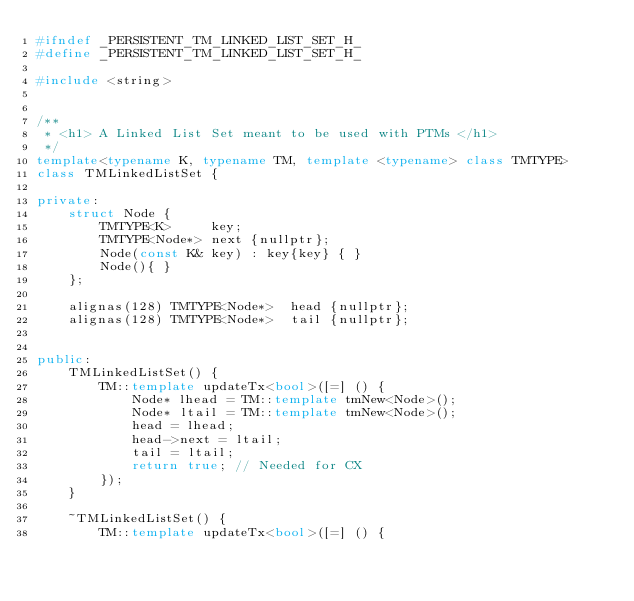<code> <loc_0><loc_0><loc_500><loc_500><_C++_>#ifndef _PERSISTENT_TM_LINKED_LIST_SET_H_
#define _PERSISTENT_TM_LINKED_LIST_SET_H_

#include <string>


/**
 * <h1> A Linked List Set meant to be used with PTMs </h1>
 */
template<typename K, typename TM, template <typename> class TMTYPE>
class TMLinkedListSet {

private:
    struct Node {
        TMTYPE<K>     key;
        TMTYPE<Node*> next {nullptr};
        Node(const K& key) : key{key} { }
        Node(){ }
    };

    alignas(128) TMTYPE<Node*>  head {nullptr};
    alignas(128) TMTYPE<Node*>  tail {nullptr};


public:
    TMLinkedListSet() {
        TM::template updateTx<bool>([=] () {
            Node* lhead = TM::template tmNew<Node>();
            Node* ltail = TM::template tmNew<Node>();
            head = lhead;
            head->next = ltail;
            tail = ltail;
            return true; // Needed for CX
        });
    }

    ~TMLinkedListSet() {
        TM::template updateTx<bool>([=] () {</code> 